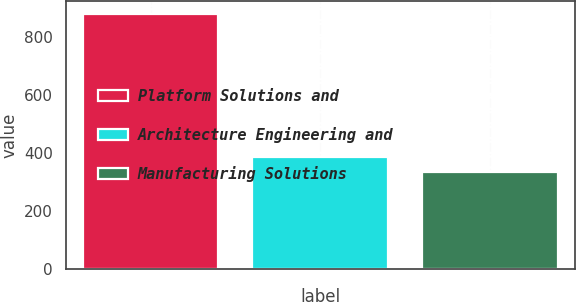Convert chart. <chart><loc_0><loc_0><loc_500><loc_500><bar_chart><fcel>Platform Solutions and<fcel>Architecture Engineering and<fcel>Manufacturing Solutions<nl><fcel>878.9<fcel>387.86<fcel>333.3<nl></chart> 